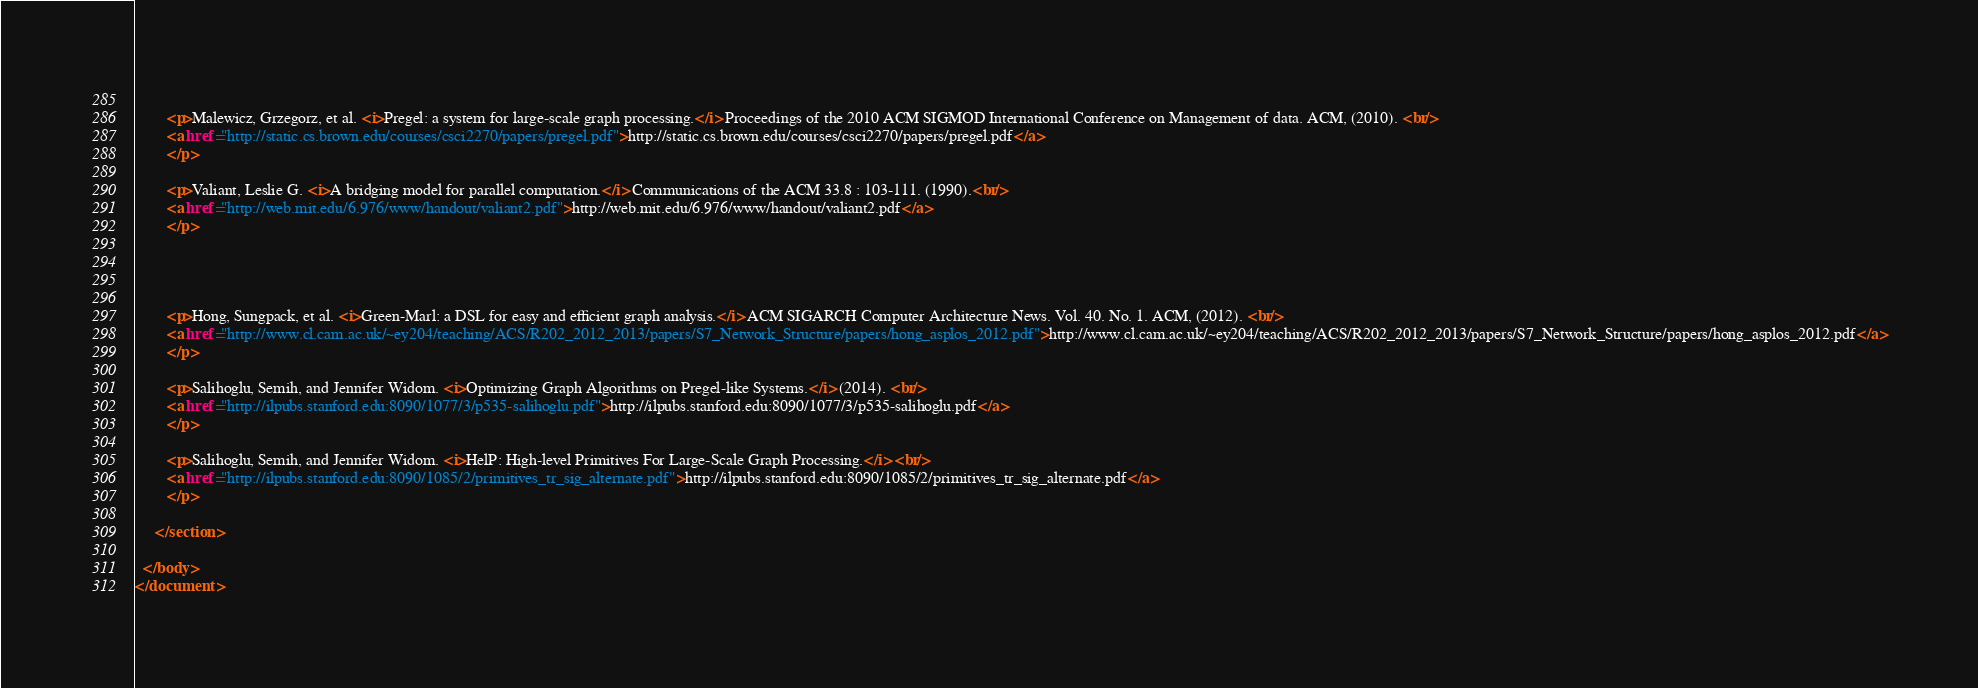<code> <loc_0><loc_0><loc_500><loc_500><_XML_>		
		<p>Malewicz, Grzegorz, et al. <i>Pregel: a system for large-scale graph processing.</i> Proceedings of the 2010 ACM SIGMOD International Conference on Management of data. ACM, (2010). <br/>
		<a href="http://static.cs.brown.edu/courses/csci2270/papers/pregel.pdf">http://static.cs.brown.edu/courses/csci2270/papers/pregel.pdf</a>
		</p>
				
     	<p>Valiant, Leslie G. <i>A bridging model for parallel computation.</i> Communications of the ACM 33.8 : 103-111. (1990).<br/>
	    <a href="http://web.mit.edu/6.976/www/handout/valiant2.pdf">http://web.mit.edu/6.976/www/handout/valiant2.pdf</a>
		</p>
		
		
		
		
		<p>Hong, Sungpack, et al. <i>Green-Marl: a DSL for easy and efficient graph analysis.</i> ACM SIGARCH Computer Architecture News. Vol. 40. No. 1. ACM, (2012). <br/>
		<a href="http://www.cl.cam.ac.uk/~ey204/teaching/ACS/R202_2012_2013/papers/S7_Network_Structure/papers/hong_asplos_2012.pdf">http://www.cl.cam.ac.uk/~ey204/teaching/ACS/R202_2012_2013/papers/S7_Network_Structure/papers/hong_asplos_2012.pdf</a>
	    </p>
	    
		<p>Salihoglu, Semih, and Jennifer Widom. <i>Optimizing Graph Algorithms on Pregel-like Systems.</i> (2014). <br/>
		<a href="http://ilpubs.stanford.edu:8090/1077/3/p535-salihoglu.pdf">http://ilpubs.stanford.edu:8090/1077/3/p535-salihoglu.pdf</a>
		</p>
		
		<p>Salihoglu, Semih, and Jennifer Widom. <i>HelP: High-level Primitives For Large-Scale Graph Processing.</i> <br/>
		<a href="http://ilpubs.stanford.edu:8090/1085/2/primitives_tr_sig_alternate.pdf">http://ilpubs.stanford.edu:8090/1085/2/primitives_tr_sig_alternate.pdf</a>
 		</p>
 		
     </section>

  </body>
</document>
</code> 